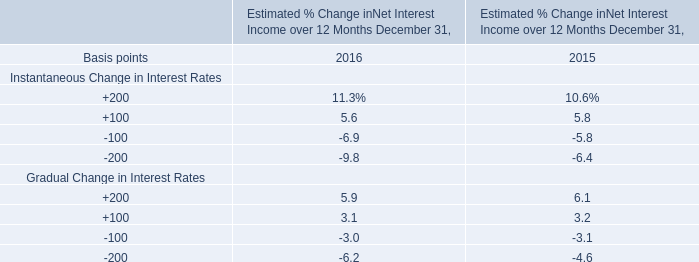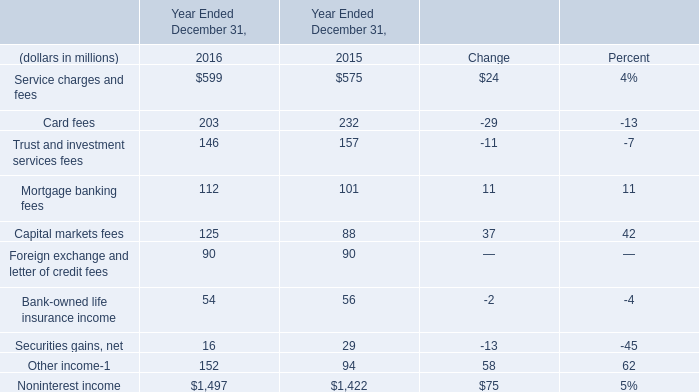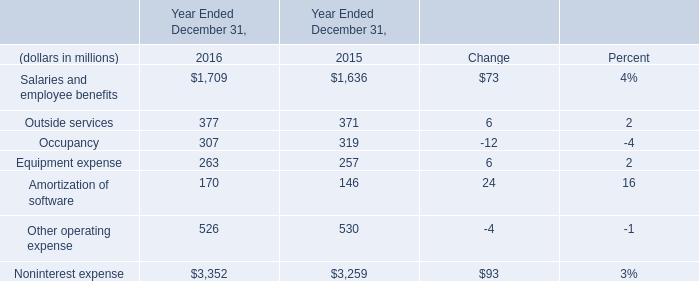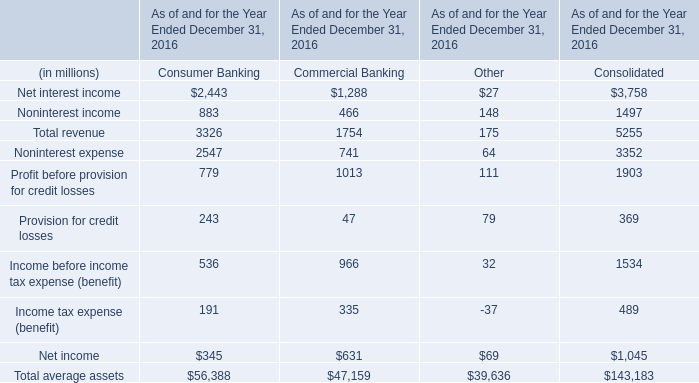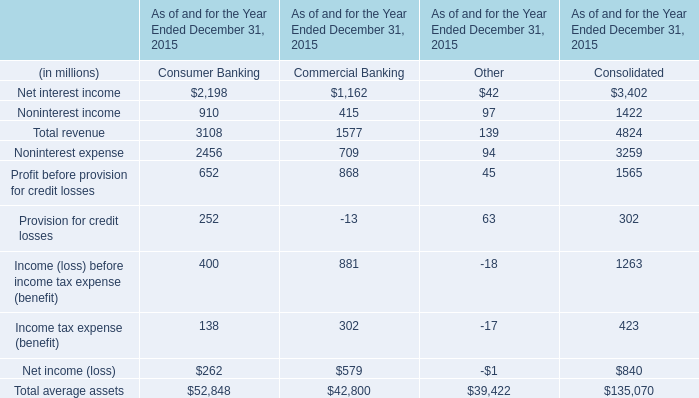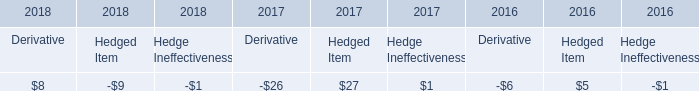What's the sum of Noninterest income of Year Ended December 31, 2016, and Noninterest expense of Year Ended December 31, 2016 ? 
Computations: (1497.0 + 3352.0)
Answer: 4849.0. 